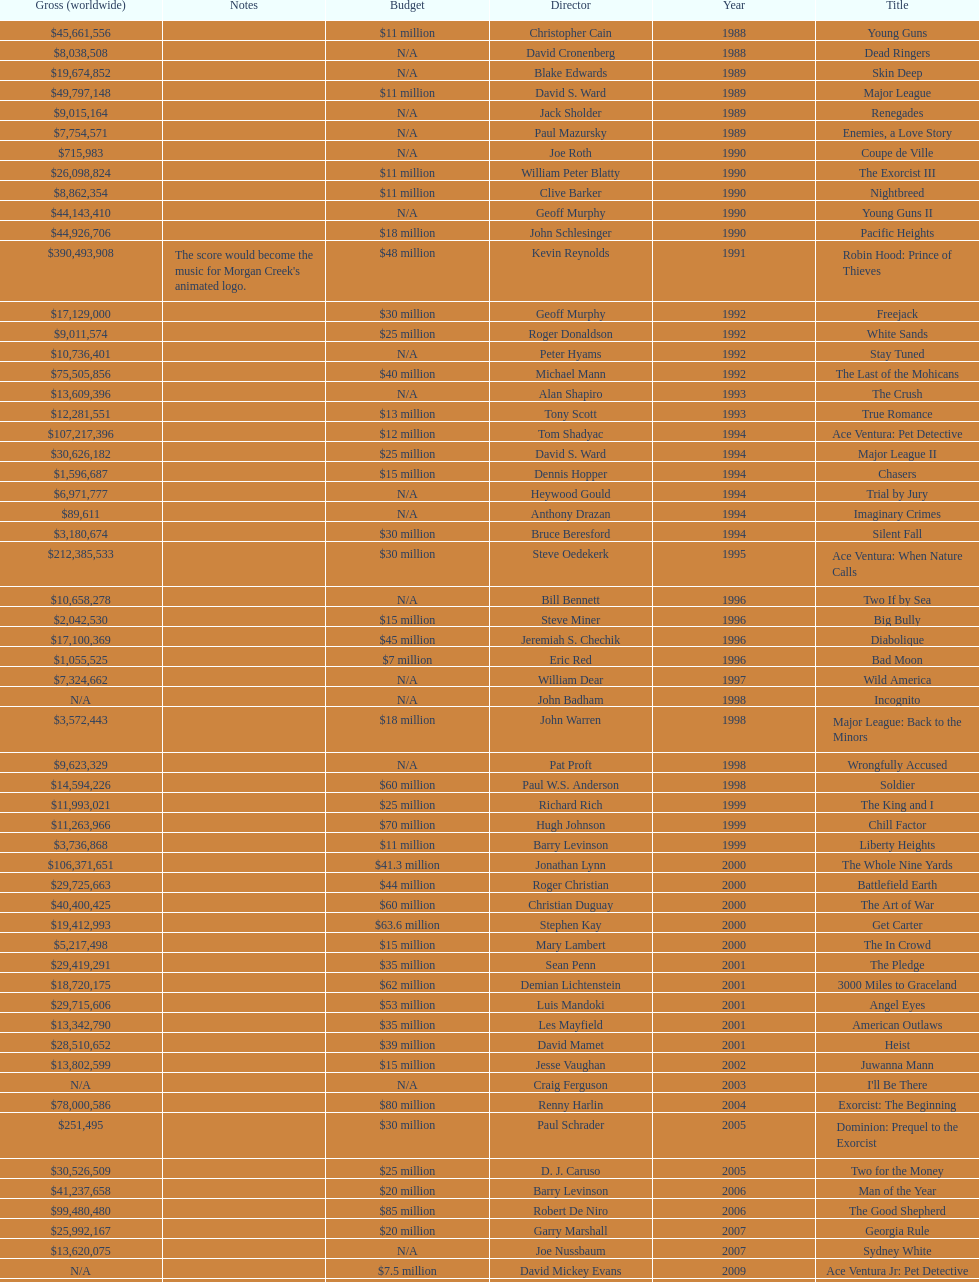After young guns, what was the next movie with the exact same budget? Major League. 